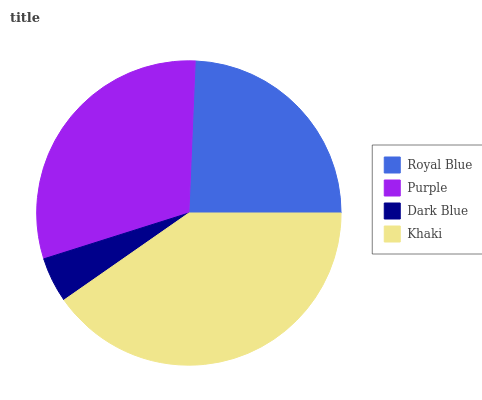Is Dark Blue the minimum?
Answer yes or no. Yes. Is Khaki the maximum?
Answer yes or no. Yes. Is Purple the minimum?
Answer yes or no. No. Is Purple the maximum?
Answer yes or no. No. Is Purple greater than Royal Blue?
Answer yes or no. Yes. Is Royal Blue less than Purple?
Answer yes or no. Yes. Is Royal Blue greater than Purple?
Answer yes or no. No. Is Purple less than Royal Blue?
Answer yes or no. No. Is Purple the high median?
Answer yes or no. Yes. Is Royal Blue the low median?
Answer yes or no. Yes. Is Dark Blue the high median?
Answer yes or no. No. Is Purple the low median?
Answer yes or no. No. 